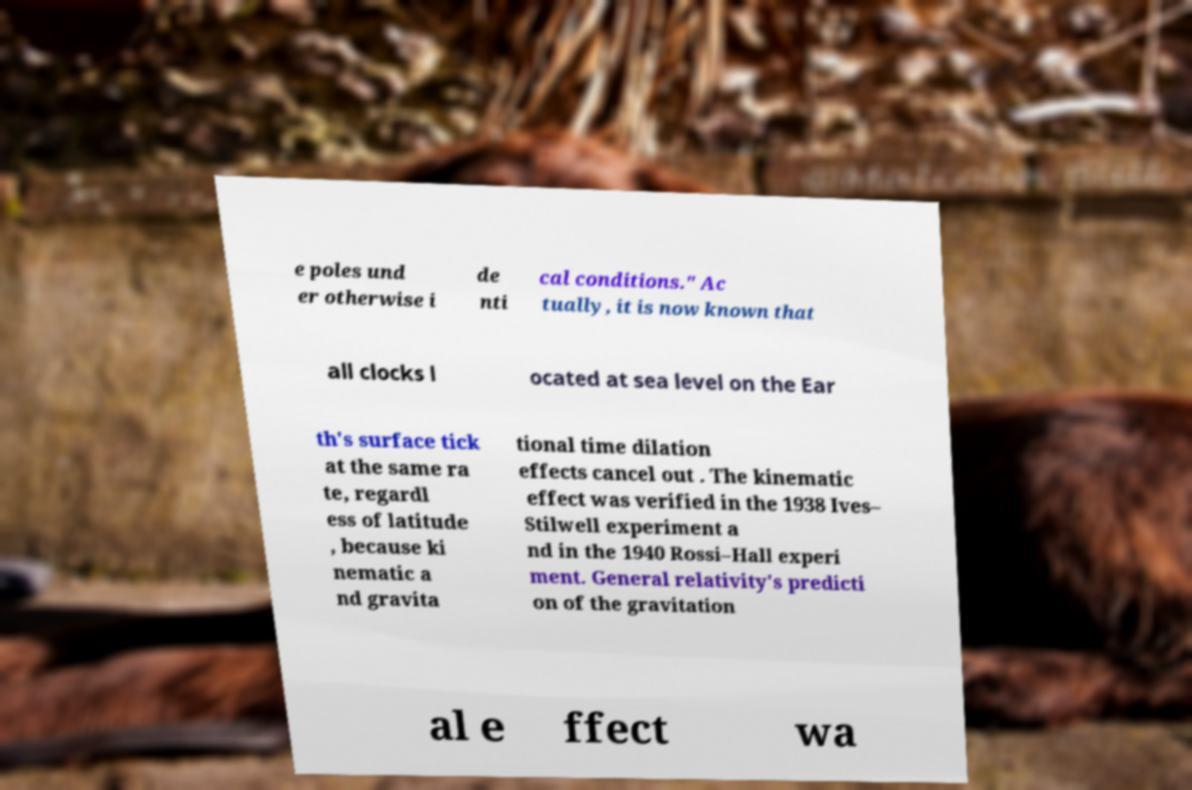Could you assist in decoding the text presented in this image and type it out clearly? e poles und er otherwise i de nti cal conditions." Ac tually, it is now known that all clocks l ocated at sea level on the Ear th's surface tick at the same ra te, regardl ess of latitude , because ki nematic a nd gravita tional time dilation effects cancel out . The kinematic effect was verified in the 1938 Ives– Stilwell experiment a nd in the 1940 Rossi–Hall experi ment. General relativity's predicti on of the gravitation al e ffect wa 